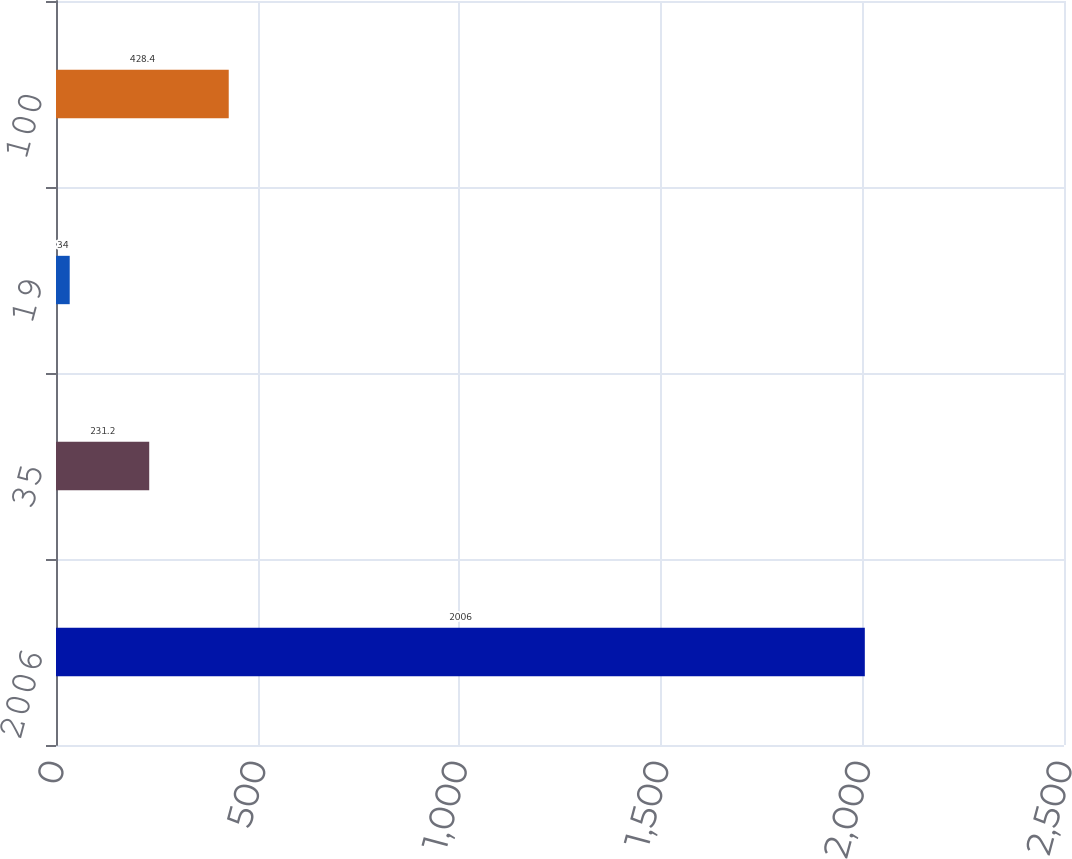Convert chart to OTSL. <chart><loc_0><loc_0><loc_500><loc_500><bar_chart><fcel>2006<fcel>35<fcel>19<fcel>100<nl><fcel>2006<fcel>231.2<fcel>34<fcel>428.4<nl></chart> 